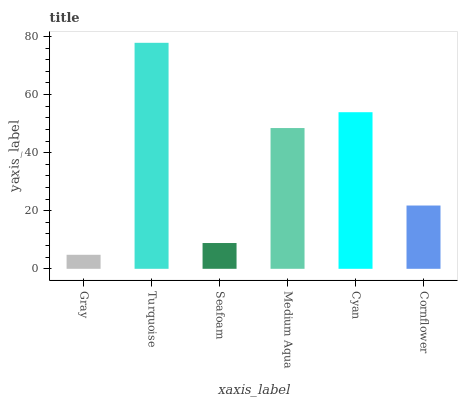Is Gray the minimum?
Answer yes or no. Yes. Is Turquoise the maximum?
Answer yes or no. Yes. Is Seafoam the minimum?
Answer yes or no. No. Is Seafoam the maximum?
Answer yes or no. No. Is Turquoise greater than Seafoam?
Answer yes or no. Yes. Is Seafoam less than Turquoise?
Answer yes or no. Yes. Is Seafoam greater than Turquoise?
Answer yes or no. No. Is Turquoise less than Seafoam?
Answer yes or no. No. Is Medium Aqua the high median?
Answer yes or no. Yes. Is Cornflower the low median?
Answer yes or no. Yes. Is Turquoise the high median?
Answer yes or no. No. Is Seafoam the low median?
Answer yes or no. No. 